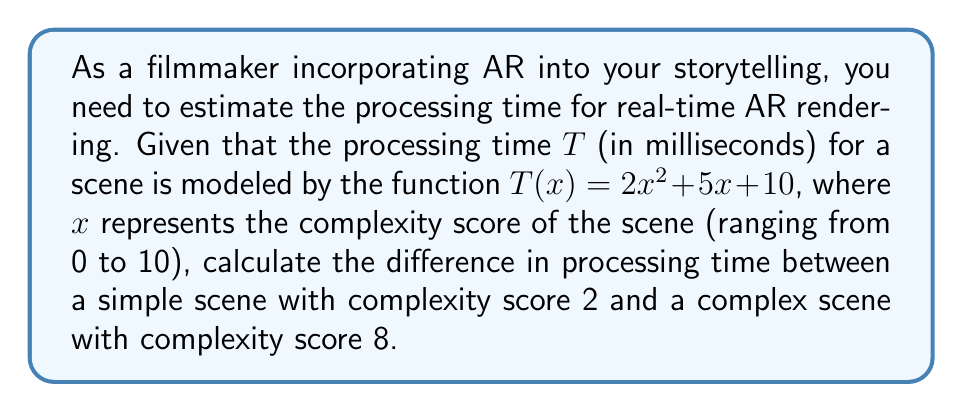Can you answer this question? To solve this problem, we'll follow these steps:

1. Calculate the processing time for the simple scene (x = 2):
   $$T(2) = 2(2)^2 + 5(2) + 10$$
   $$T(2) = 2(4) + 10 + 10$$
   $$T(2) = 8 + 10 + 10 = 28 \text{ ms}$$

2. Calculate the processing time for the complex scene (x = 8):
   $$T(8) = 2(8)^2 + 5(8) + 10$$
   $$T(8) = 2(64) + 40 + 10$$
   $$T(8) = 128 + 40 + 10 = 178 \text{ ms}$$

3. Calculate the difference in processing time:
   $$\text{Difference} = T(8) - T(2)$$
   $$\text{Difference} = 178 - 28 = 150 \text{ ms}$$

This result shows that the complex scene requires 150 milliseconds more processing time than the simple scene for real-time AR rendering.
Answer: 150 ms 